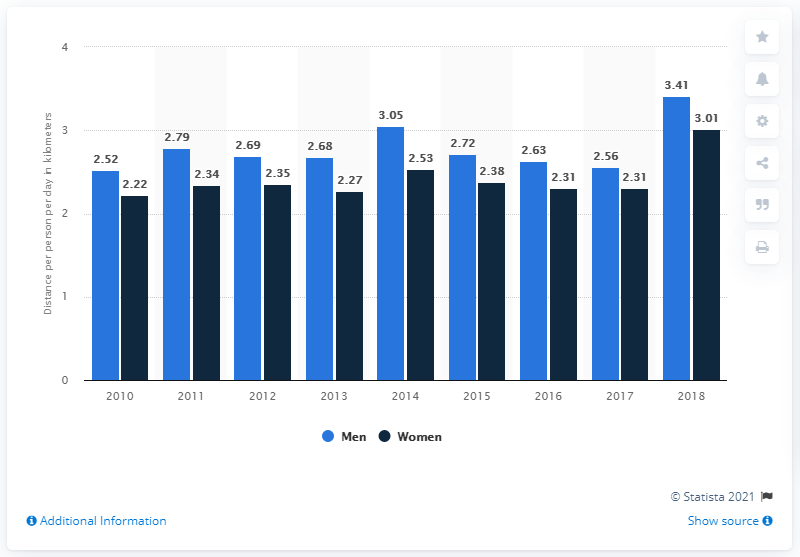Specify some key components in this picture. The average daily biking distance per person in the Netherlands from 2010 was 4.74 kilometers. In the Netherlands, the average biking distance per person per day for males was 2.52 kilometers from 2010. 